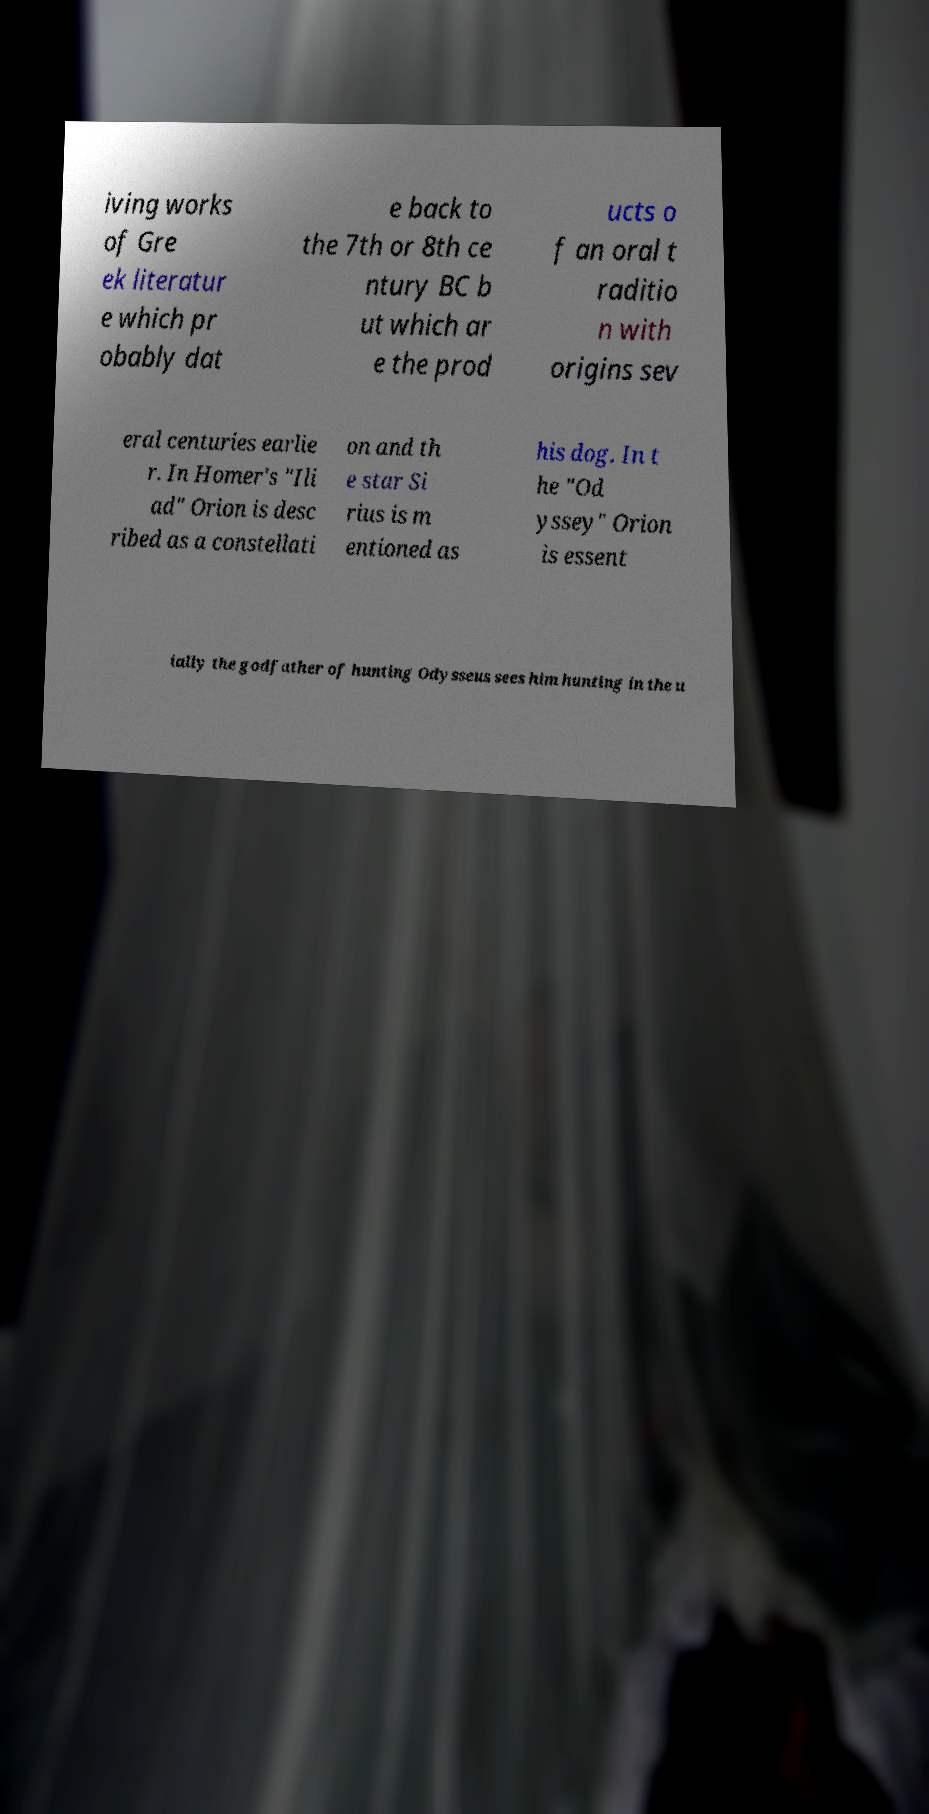Can you accurately transcribe the text from the provided image for me? iving works of Gre ek literatur e which pr obably dat e back to the 7th or 8th ce ntury BC b ut which ar e the prod ucts o f an oral t raditio n with origins sev eral centuries earlie r. In Homer's "Ili ad" Orion is desc ribed as a constellati on and th e star Si rius is m entioned as his dog. In t he "Od yssey" Orion is essent ially the godfather of hunting Odysseus sees him hunting in the u 